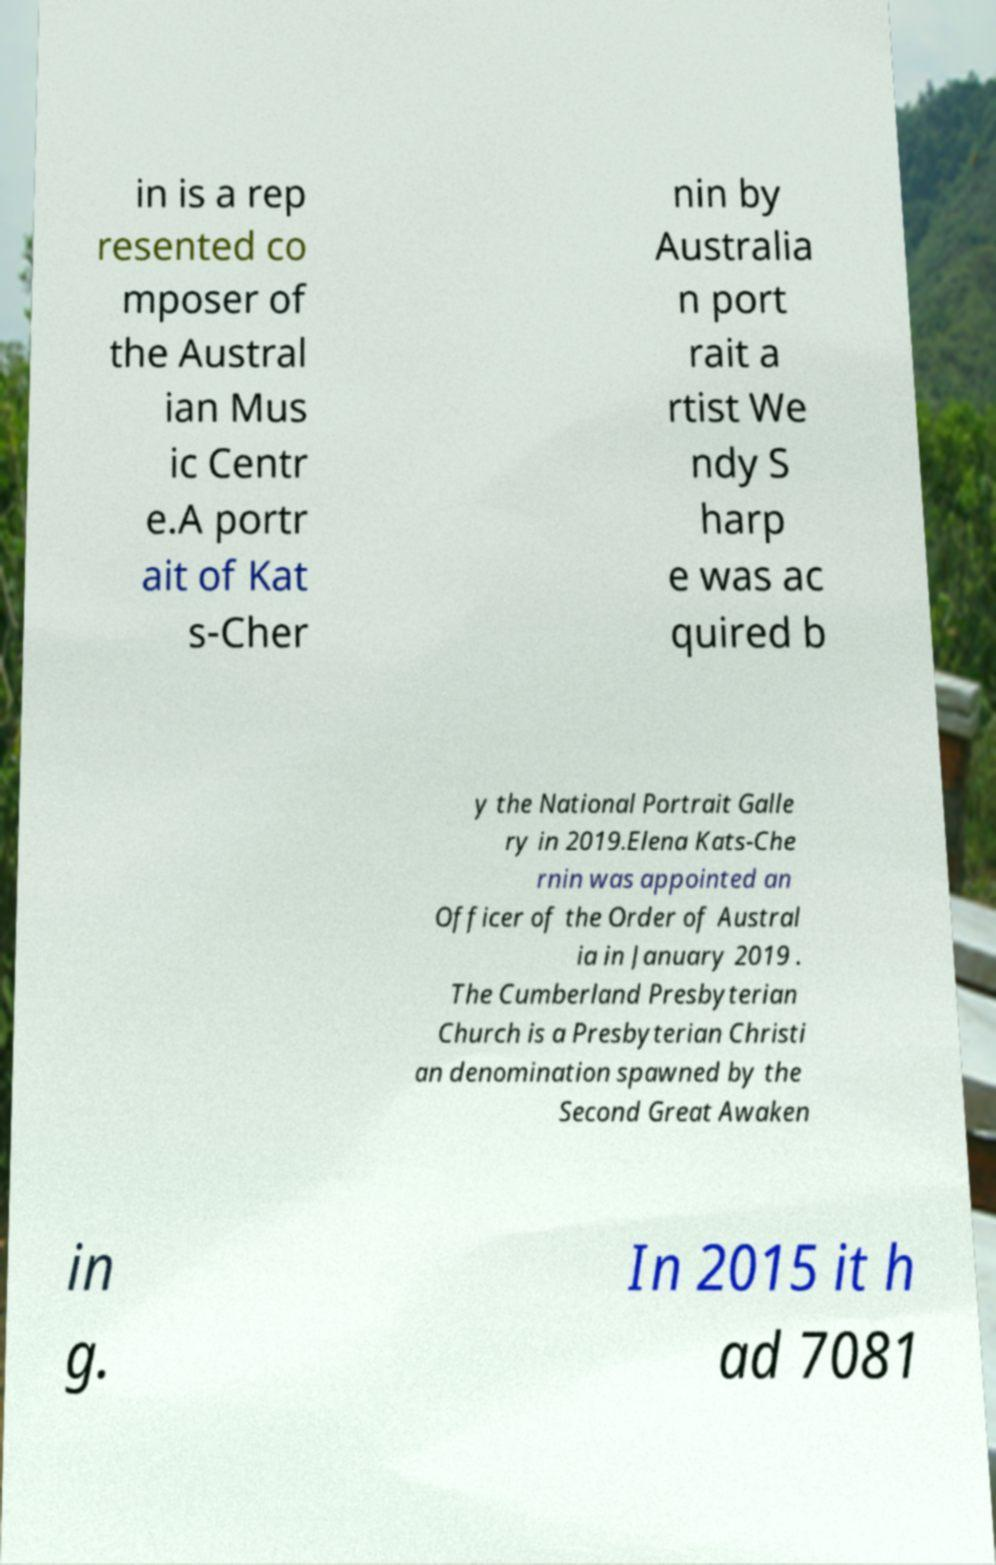For documentation purposes, I need the text within this image transcribed. Could you provide that? in is a rep resented co mposer of the Austral ian Mus ic Centr e.A portr ait of Kat s-Cher nin by Australia n port rait a rtist We ndy S harp e was ac quired b y the National Portrait Galle ry in 2019.Elena Kats-Che rnin was appointed an Officer of the Order of Austral ia in January 2019 . The Cumberland Presbyterian Church is a Presbyterian Christi an denomination spawned by the Second Great Awaken in g. In 2015 it h ad 7081 